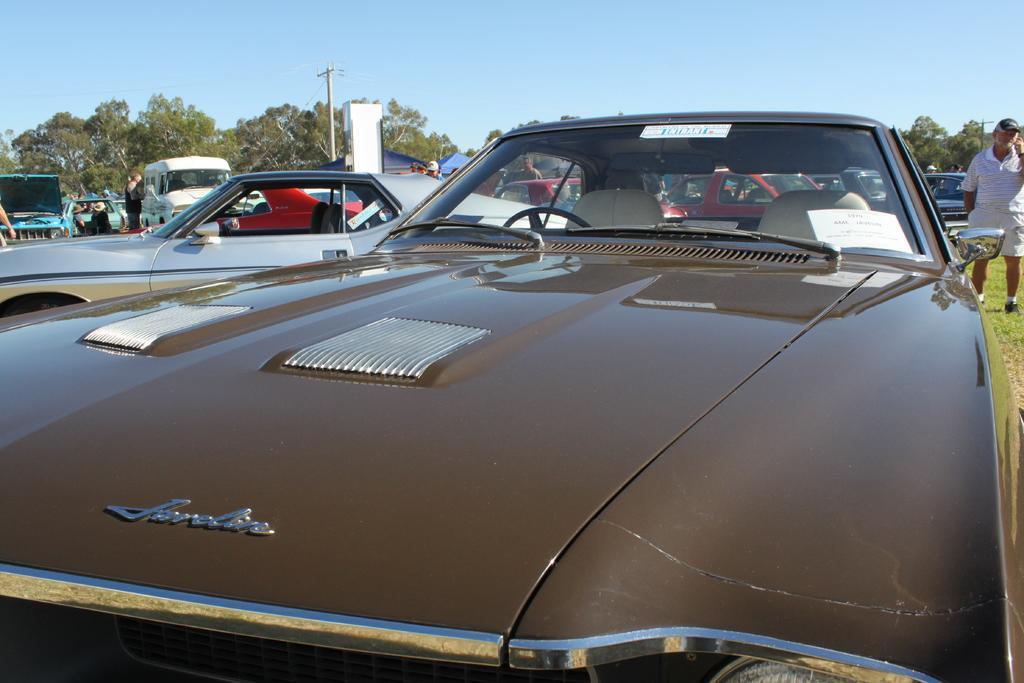Describe this image in one or two sentences. In the foreground of this image, there is a brown color car. On the right, there is a man standing. In the background, there are vehicles, poles, trees and the sky. 